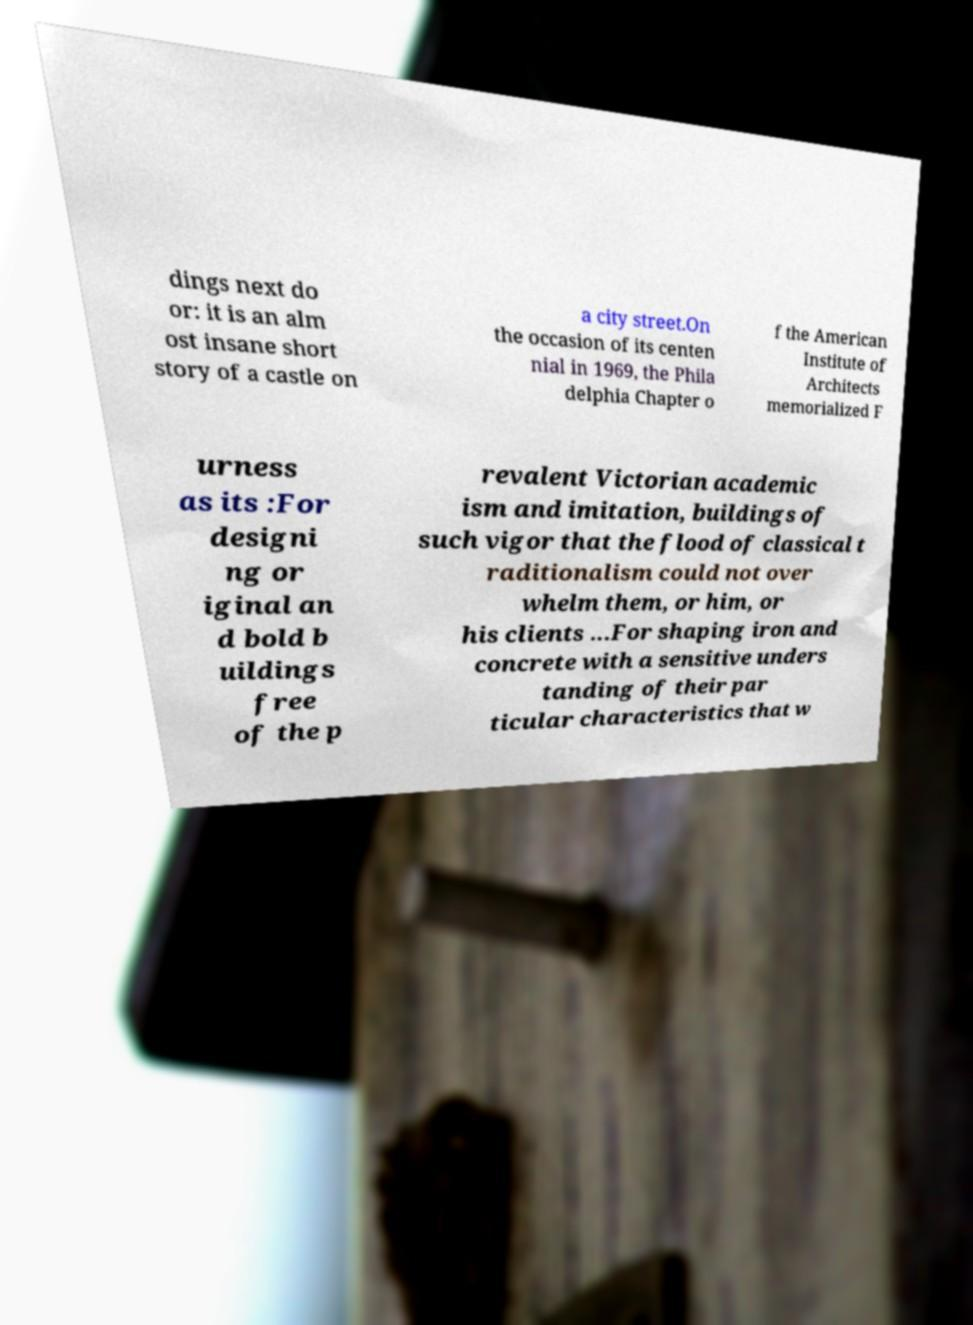Please read and relay the text visible in this image. What does it say? dings next do or: it is an alm ost insane short story of a castle on a city street.On the occasion of its centen nial in 1969, the Phila delphia Chapter o f the American Institute of Architects memorialized F urness as its :For designi ng or iginal an d bold b uildings free of the p revalent Victorian academic ism and imitation, buildings of such vigor that the flood of classical t raditionalism could not over whelm them, or him, or his clients ...For shaping iron and concrete with a sensitive unders tanding of their par ticular characteristics that w 